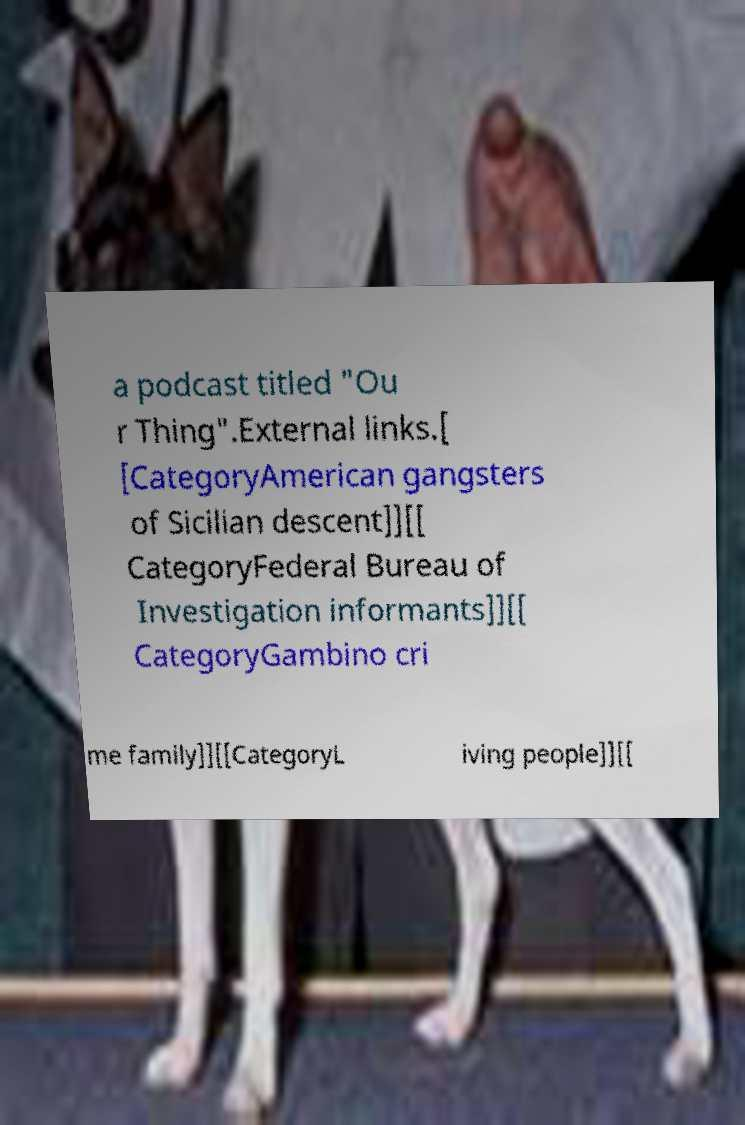Can you read and provide the text displayed in the image?This photo seems to have some interesting text. Can you extract and type it out for me? a podcast titled "Ou r Thing".External links.[ [CategoryAmerican gangsters of Sicilian descent]][[ CategoryFederal Bureau of Investigation informants]][[ CategoryGambino cri me family]][[CategoryL iving people]][[ 